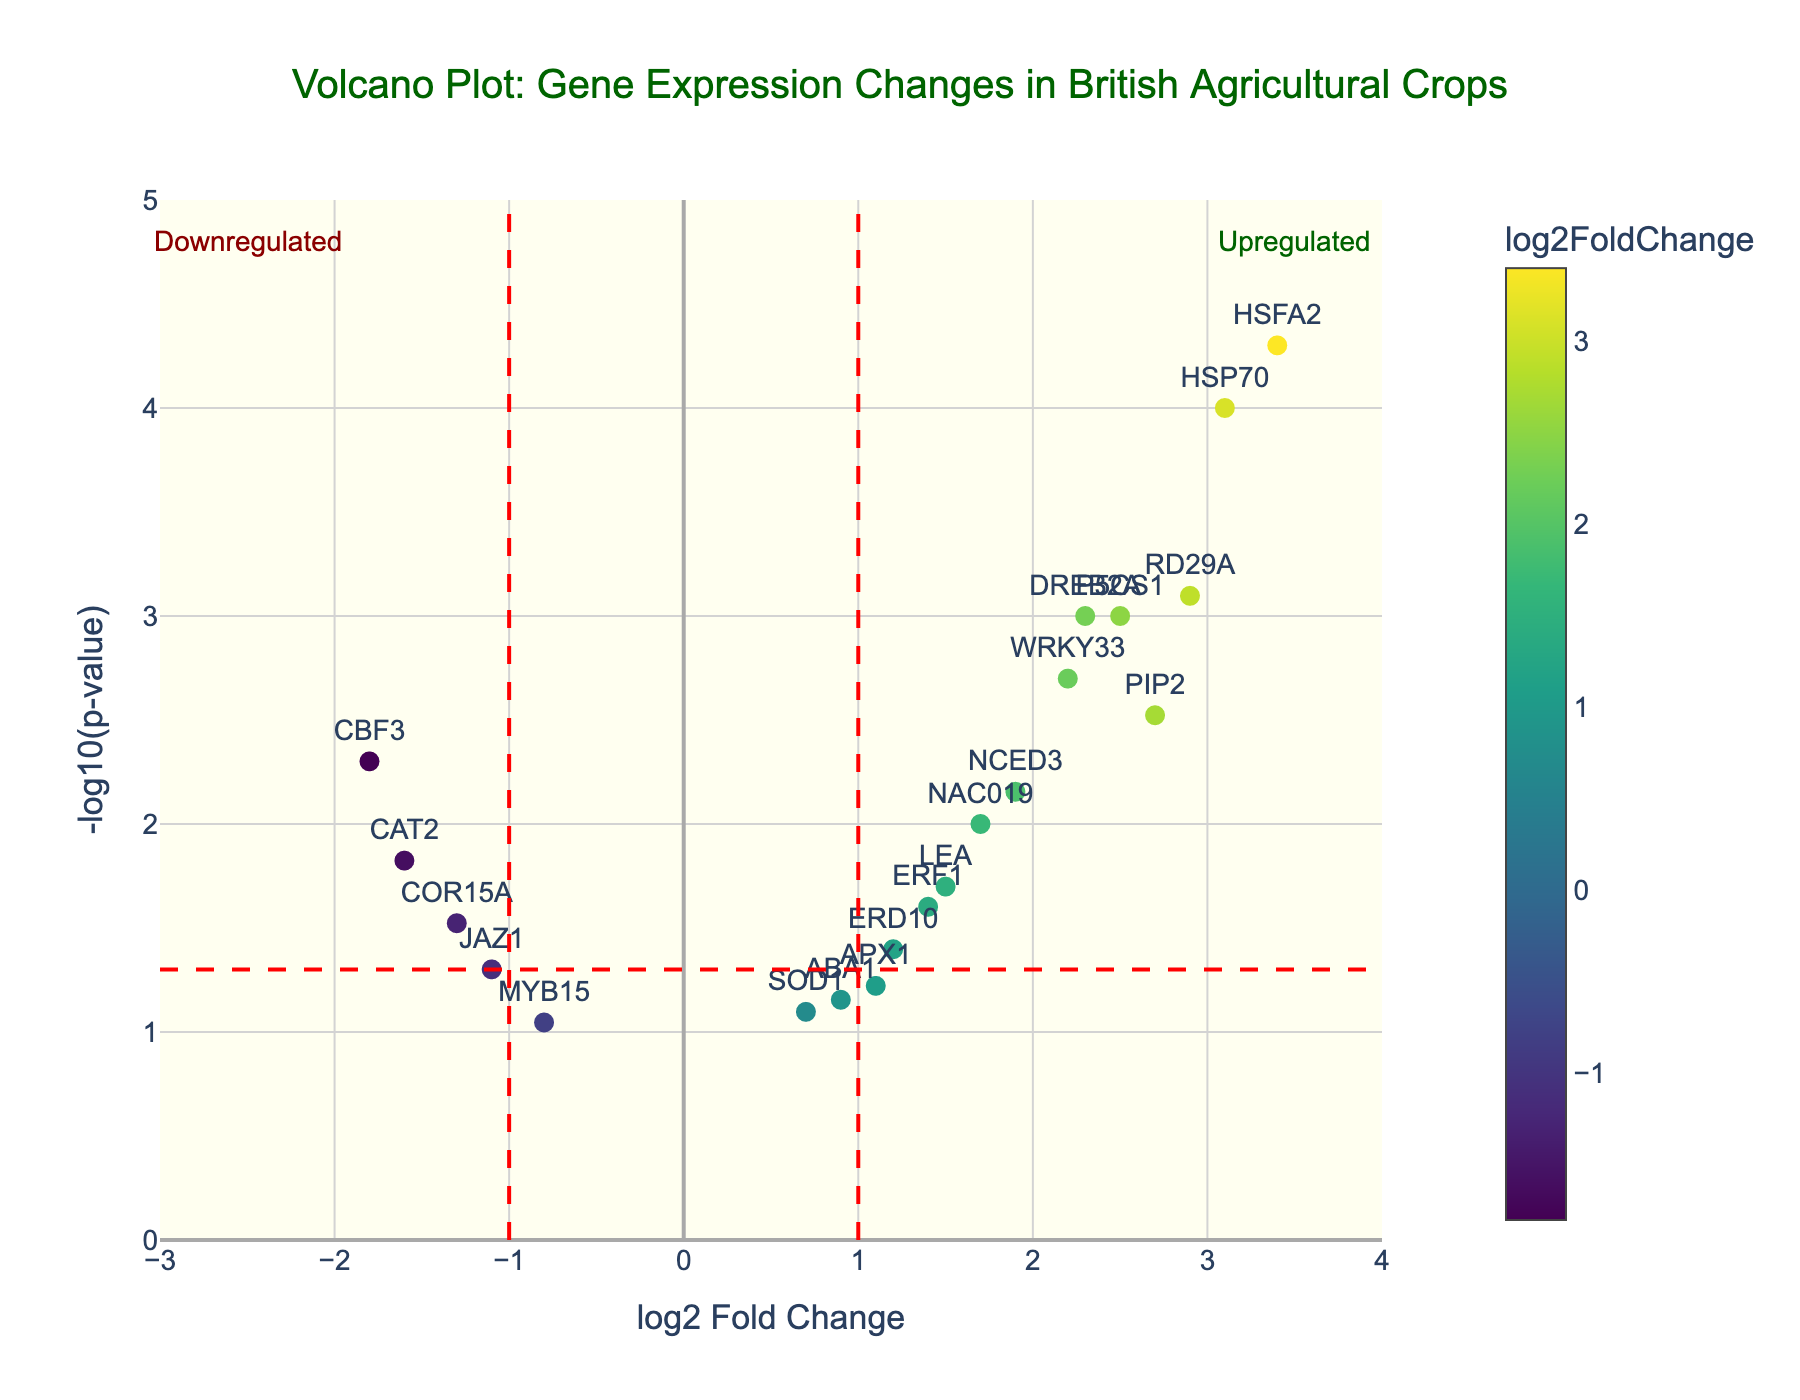What is the title of the figure? The title of the figure is normally displayed at the top. In this figure, the title is clear and detailed.
Answer: Volcano Plot: Gene Expression Changes in British Agricultural Crops What are the x and y axes labeling? The x-axis represents 'log2 Fold Change', and the y-axis represents '-log10(p-value)'. This information can be found at the bottom and left sides of the plot respectively.
Answer: log2 Fold Change, -log10(p-value) How many genes have a log2 fold change greater than 2? Look for data points to the right of the vertical line at log2 fold change = 2. Identify points above this threshold. HSFA2, HSP70, RD29A, PIP2, and DREB2A are above 2.
Answer: 5 Which gene has the most significant change in expression (smallest p-value)? The most significant change will be the highest point on the y-axis since it represents -log10(p-value). The highest point on this axis is HSFA2.
Answer: HSFA2 Which gene has the highest log2 fold change? The gene with the highest log2 fold change will be the farthest right on the x-axis. Looking at the farthest right point, it is HSFA2.
Answer: HSFA2 Are there more upregulated or downregulated genes? Count data points to the right of log2 fold change = 1 (upregulated) and left of log2 fold change = -1 (downregulated). There are more points right of 1 than left of -1.
Answer: More upregulated Name three genes that are significantly upregulated. Look for genes to the right of the log2 fold change = 1 line and above the –log10(p-value) = 1.3 line (p-value < 0.05). Examples: HSFA2, HSP70, RD29A.
Answer: HSFA2, HSP70, RD29A Which genes are both downregulated and significant? Look for genes to the left of the log2 fold change = -1 line and above the -log10(p-value) = 1.3 line (p-value < 0.05). Examples: CBF3, CAT2.
Answer: CBF3, CAT2 What does the red dashed horizontal line represent? The red dashed horizontal line represents the p-value threshold of 0.05, converted to the -log10(p-value) scale. This can be identified in the legend or through its position on the y-axis.
Answer: p-value threshold How many genes have a p-value less than 0.05? Count the points above the red dashed horizontal line at approximately -log10(p-value) = 1.3. Counting these gives 11 genes.
Answer: 11 